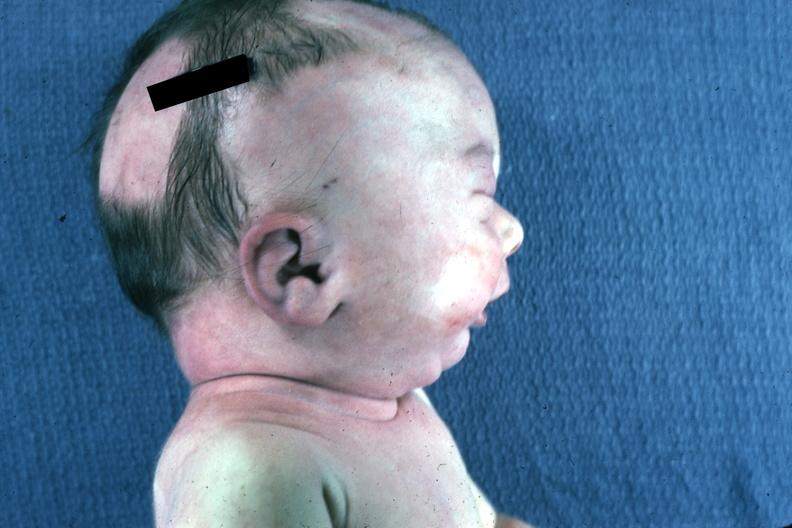s potters facies present?
Answer the question using a single word or phrase. Yes 